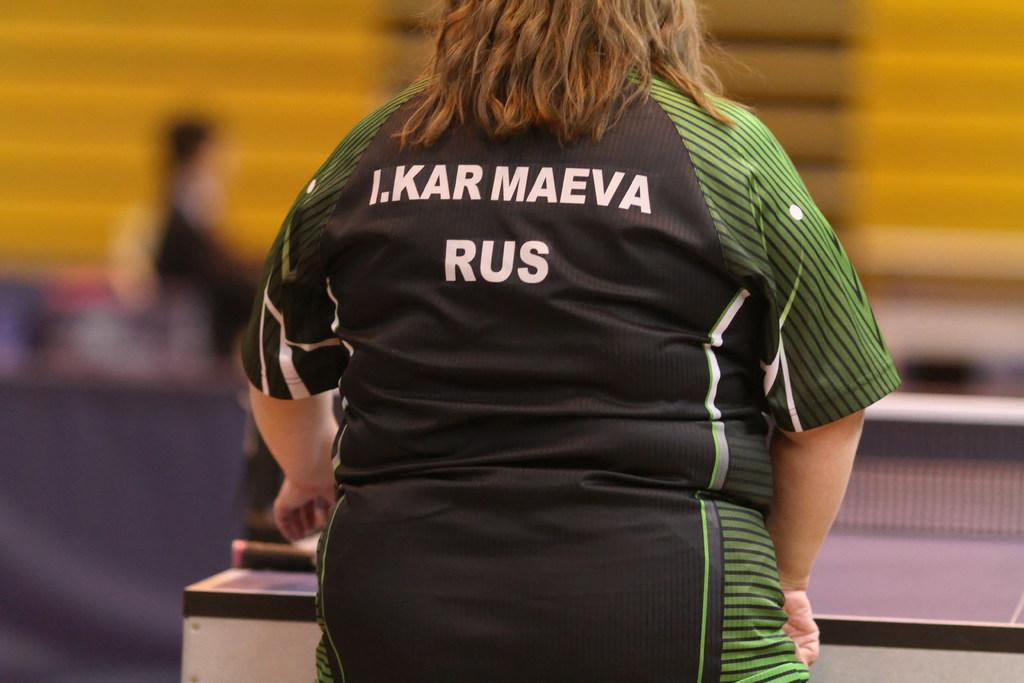<image>
Offer a succinct explanation of the picture presented. A woman wears a black and green jersey with I.Kar Maeva Rus on the back. 